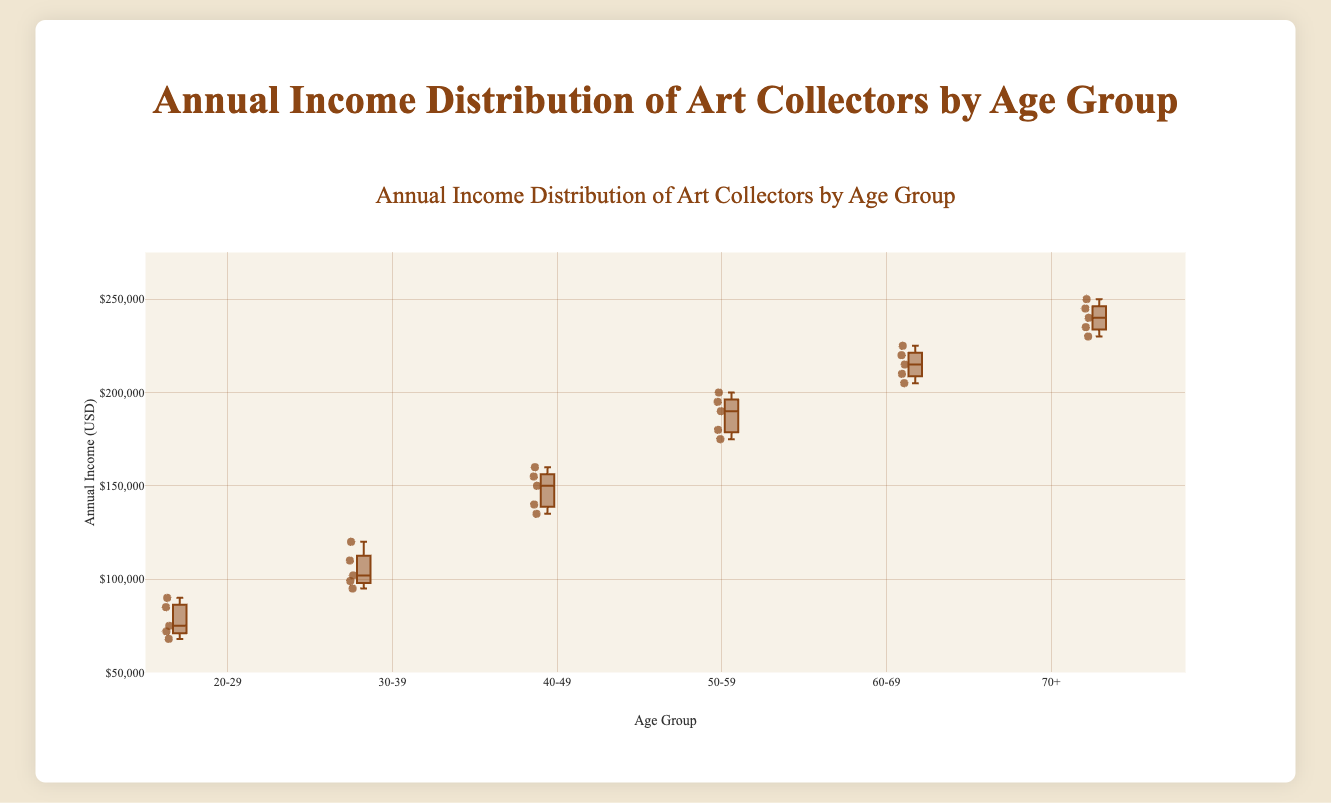What is the title of the figure? The title is displayed at the top of the figure and reads "Annual Income Distribution of Art Collectors by Age Group".
Answer: Annual Income Distribution of Art Collectors by Age Group Which age group has the highest median annual income? The highest median annual income is visually represented by the line in the center of the box, which is highest in the "70+" age group box.
Answer: 70+ What is the income range for the 60-69 age group? The income range is determined by the bottom and top "whiskers" of the box plot for the 60-69 age group. These extend from $205,000 (minimum) to $225,000 (maximum).
Answer: $205,000 to $225,000 How does the median income of the 20-29 age group compare to the 40-49 age group? The median income is represented by the line inside the box. The median income for the 20-29 age group is significantly lower than that of the 40-49 age group.
Answer: Lower What is the interquartile range (IQR) for the 50-59 age group? The IQR is the difference between the first quartile (Q1) and the third quartile (Q3). By visually estimating, Q1 is around $175,000 and Q3 is around $195,000 for the 50-59 age group. Therefore, the IQR = $195,000 - $175,000.
Answer: $20,000 Which age group shows the largest variation in annual income? The largest variation is represented by the longest distance between the bottom and top whiskers. It appears the "70+" group shows the largest variation.
Answer: 70+ What are the lower and upper whiskers' values for the 40-49 age group? The lower whisker is at $135,000, and the upper whisker is at $160,000 for the 40-49 age group.
Answer: $135,000 and $160,000 Which age group has the smallest interquartile range (IQR)? The smallest IQR is visually represented by the shortest distance between the lower and upper bounds of the box. The 30-39 age group has the smallest IQR.
Answer: 30-39 What is the minimum annual income in the dataset? The minimum annual income is represented by the lowest whisker across all age groups. In this dataset, it is in the 20-29 age group, which is $68,000.
Answer: $68,000 How does the median income of collectors aged 30-39 compare to those aged 50-59? The median income for each age group is identified by the line inside the box. The median income for the 50-59 group is higher than that of the 30-39 group.
Answer: Higher 